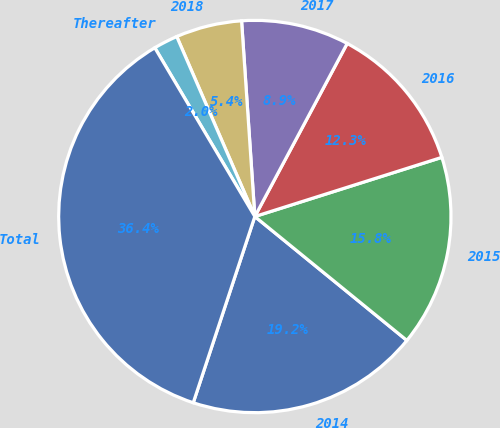Convert chart. <chart><loc_0><loc_0><loc_500><loc_500><pie_chart><fcel>2014<fcel>2015<fcel>2016<fcel>2017<fcel>2018<fcel>Thereafter<fcel>Total<nl><fcel>19.2%<fcel>15.76%<fcel>12.32%<fcel>8.88%<fcel>5.44%<fcel>2.0%<fcel>36.4%<nl></chart> 